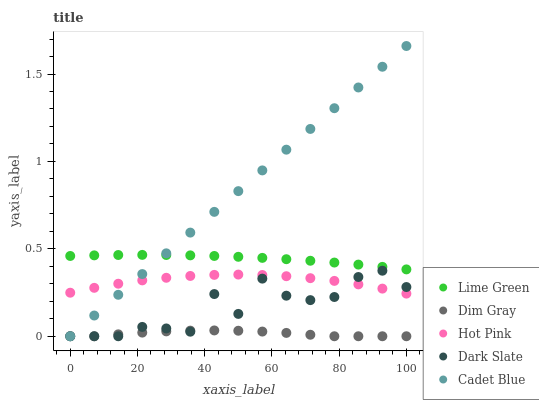Does Dim Gray have the minimum area under the curve?
Answer yes or no. Yes. Does Cadet Blue have the maximum area under the curve?
Answer yes or no. Yes. Does Dark Slate have the minimum area under the curve?
Answer yes or no. No. Does Dark Slate have the maximum area under the curve?
Answer yes or no. No. Is Cadet Blue the smoothest?
Answer yes or no. Yes. Is Dark Slate the roughest?
Answer yes or no. Yes. Is Dim Gray the smoothest?
Answer yes or no. No. Is Dim Gray the roughest?
Answer yes or no. No. Does Cadet Blue have the lowest value?
Answer yes or no. Yes. Does Lime Green have the lowest value?
Answer yes or no. No. Does Cadet Blue have the highest value?
Answer yes or no. Yes. Does Dark Slate have the highest value?
Answer yes or no. No. Is Dim Gray less than Lime Green?
Answer yes or no. Yes. Is Lime Green greater than Hot Pink?
Answer yes or no. Yes. Does Cadet Blue intersect Hot Pink?
Answer yes or no. Yes. Is Cadet Blue less than Hot Pink?
Answer yes or no. No. Is Cadet Blue greater than Hot Pink?
Answer yes or no. No. Does Dim Gray intersect Lime Green?
Answer yes or no. No. 